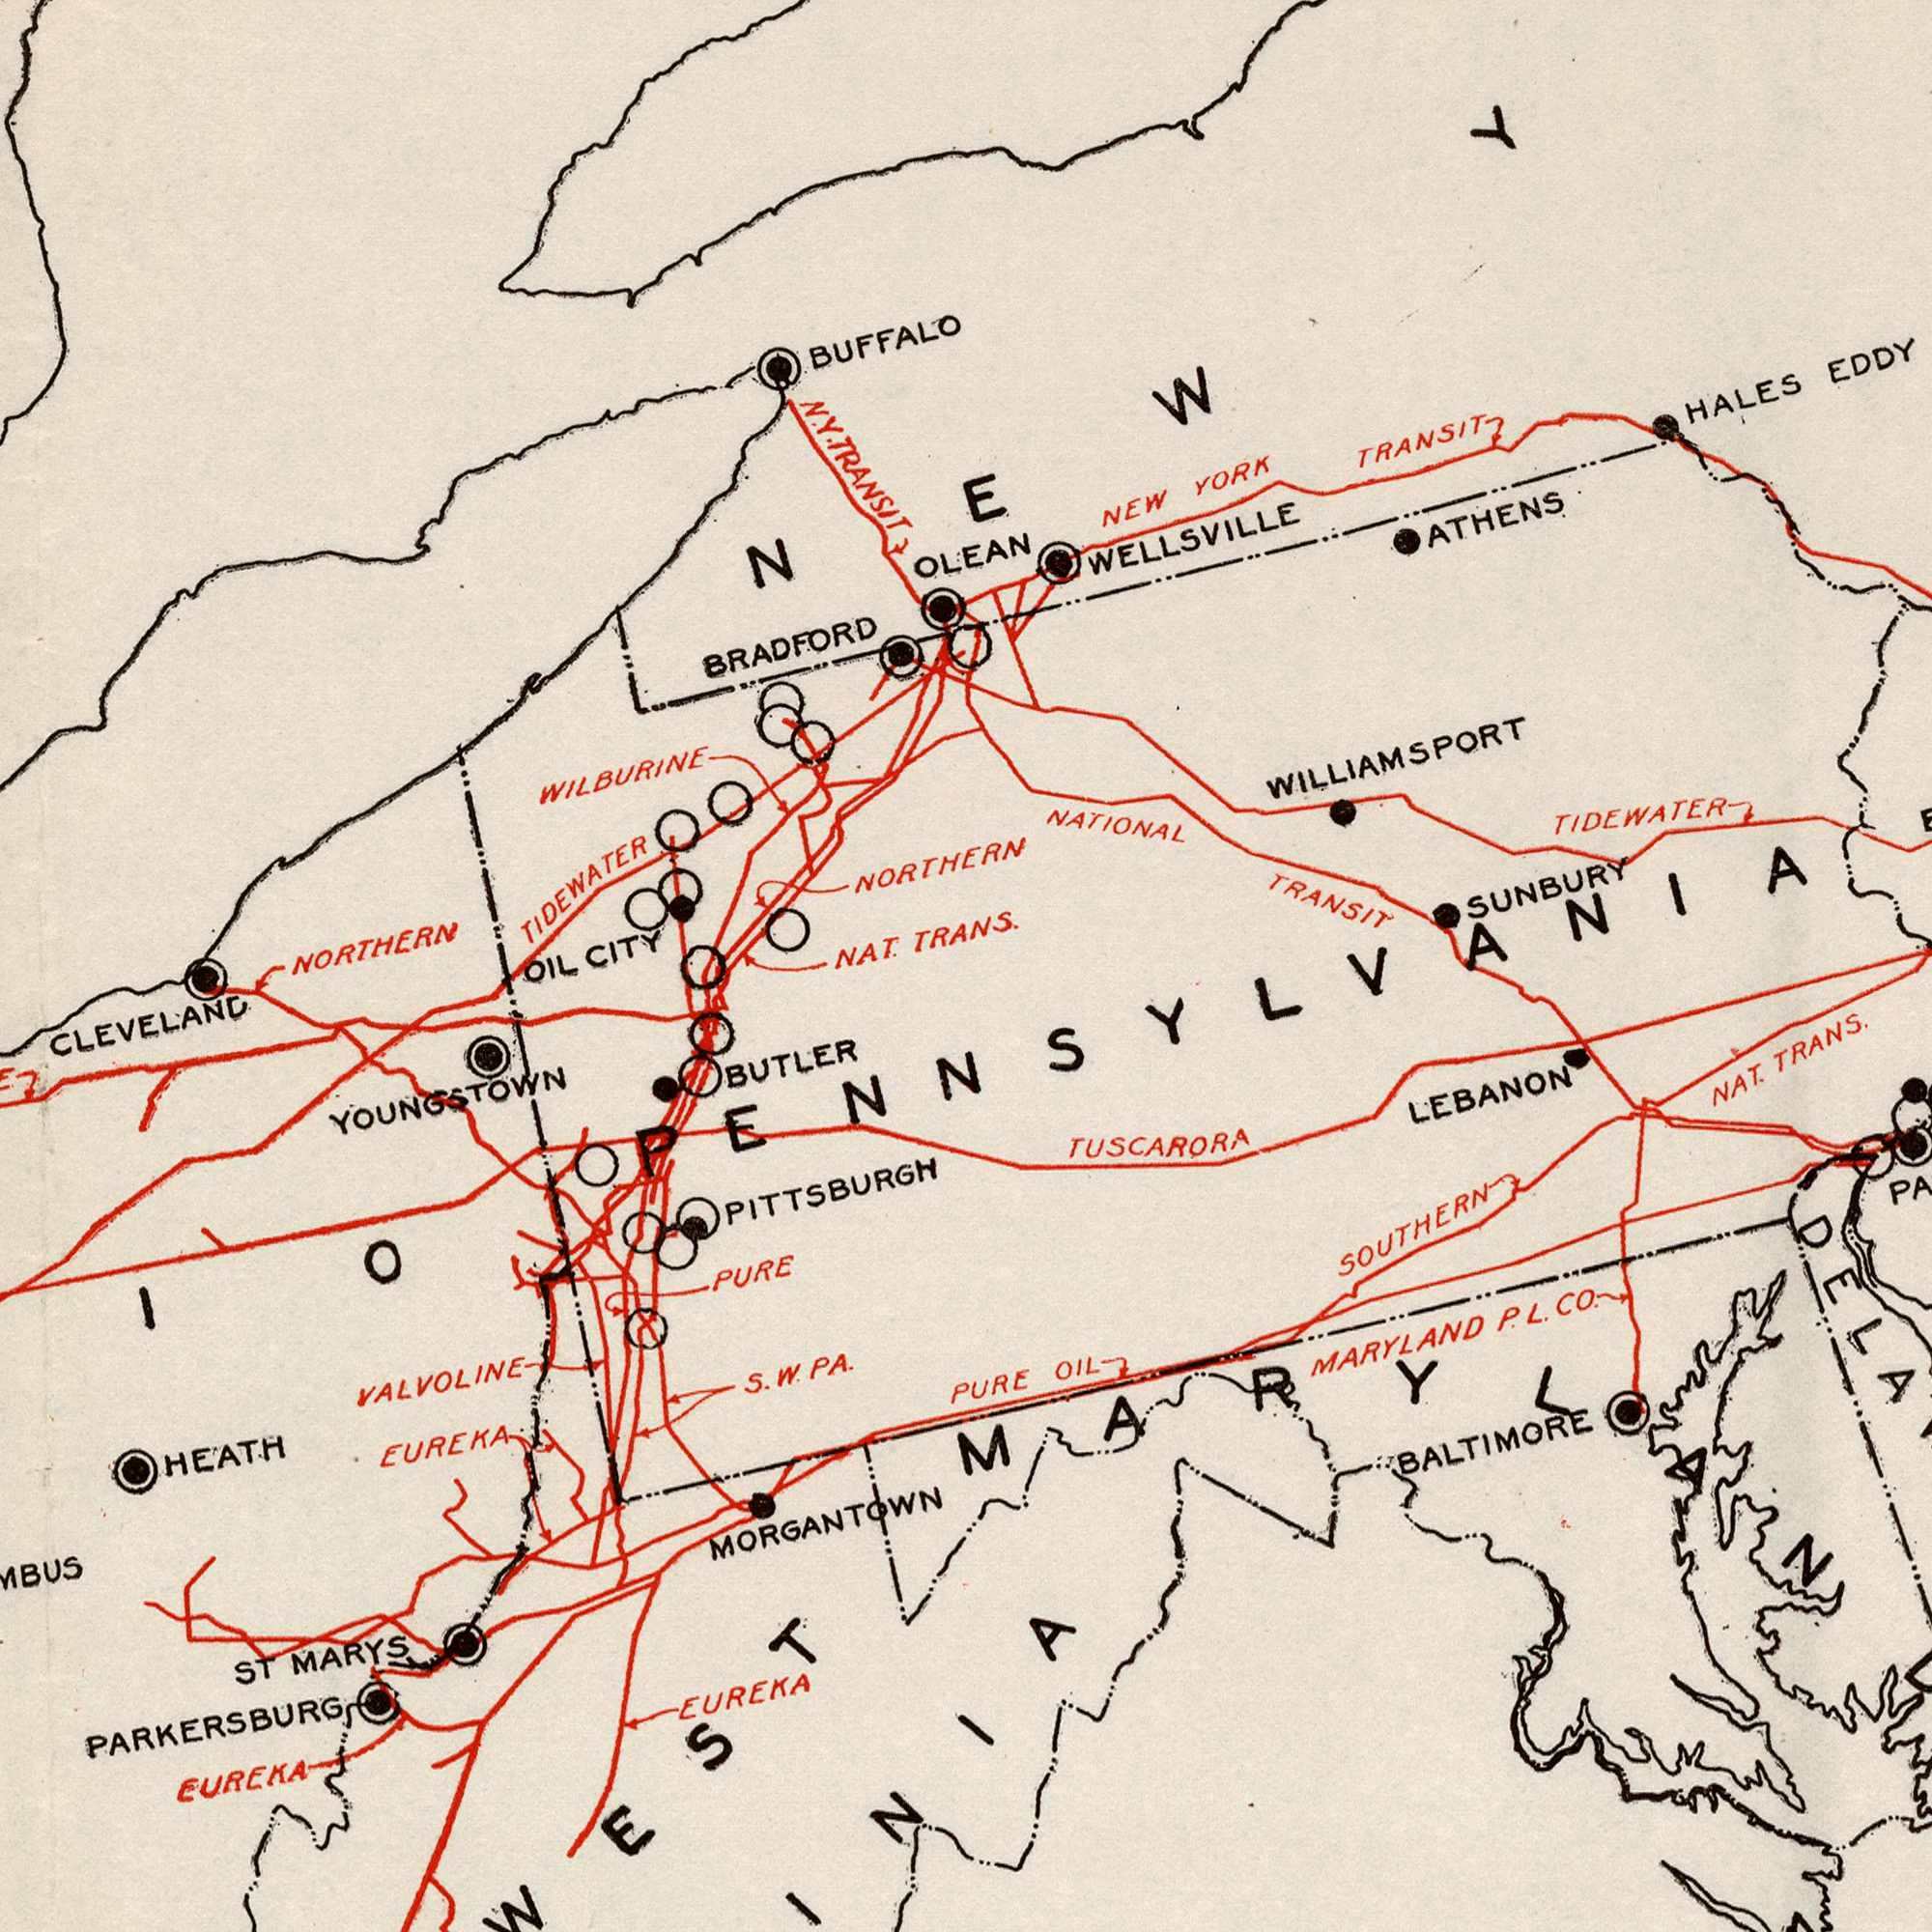What text appears in the top-left area of the image? BUFFALO TIDEWATER NORTHERN BRADFORD NAT. TRANS. NORTHERN CITY TRANSIT WILBURINE OLEAN CLEVELAND N. Y. OIL NEW What text is shown in the bottom-right quadrant? MARYLAND LEBANON SOUTHERN NAT. OIL PURE BALTIMORE CO. P. TUSCARORA L. What text appears in the top-right area of the image? TRANSIT TIDEWATER HALES NEW YORK SUNBURY TRANSIT EDDY NATIONAL ATHENS WILLIAMSPORT WELLSVILLE TRANS. PENNSYLVANIA What text appears in the bottom-left area of the image? EUREKA EUREKA YOUNGSTOWN MORGANTOWN BUTLER PURE EUREKA HEATH MARYS ST PARKERSBURG PA. VALVOLINE PITTSBURGH S. W. 